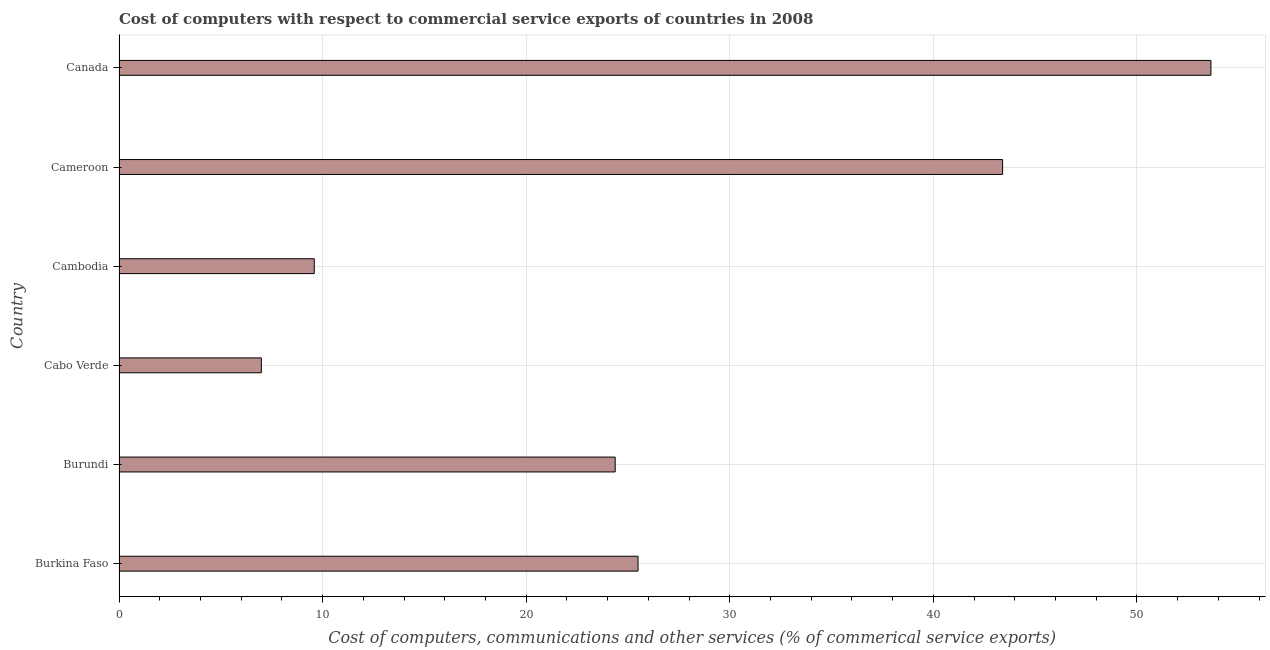Does the graph contain any zero values?
Ensure brevity in your answer.  No. What is the title of the graph?
Make the answer very short. Cost of computers with respect to commercial service exports of countries in 2008. What is the label or title of the X-axis?
Keep it short and to the point. Cost of computers, communications and other services (% of commerical service exports). What is the cost of communications in Cabo Verde?
Give a very brief answer. 6.99. Across all countries, what is the maximum  computer and other services?
Keep it short and to the point. 53.63. Across all countries, what is the minimum  computer and other services?
Your answer should be compact. 6.99. In which country was the  computer and other services minimum?
Keep it short and to the point. Cabo Verde. What is the sum of the cost of communications?
Your answer should be compact. 163.47. What is the difference between the cost of communications in Burkina Faso and Cambodia?
Provide a succinct answer. 15.9. What is the average cost of communications per country?
Offer a terse response. 27.25. What is the median cost of communications?
Provide a short and direct response. 24.93. In how many countries, is the cost of communications greater than 50 %?
Offer a very short reply. 1. What is the ratio of the cost of communications in Burundi to that in Cambodia?
Ensure brevity in your answer.  2.54. What is the difference between the highest and the second highest  computer and other services?
Provide a succinct answer. 10.23. Is the sum of the cost of communications in Cabo Verde and Cambodia greater than the maximum cost of communications across all countries?
Provide a succinct answer. No. What is the difference between the highest and the lowest  computer and other services?
Your answer should be very brief. 46.64. How many bars are there?
Provide a short and direct response. 6. How many countries are there in the graph?
Your answer should be very brief. 6. What is the difference between two consecutive major ticks on the X-axis?
Provide a succinct answer. 10. Are the values on the major ticks of X-axis written in scientific E-notation?
Your response must be concise. No. What is the Cost of computers, communications and other services (% of commerical service exports) of Burkina Faso?
Ensure brevity in your answer.  25.49. What is the Cost of computers, communications and other services (% of commerical service exports) in Burundi?
Your answer should be very brief. 24.37. What is the Cost of computers, communications and other services (% of commerical service exports) in Cabo Verde?
Offer a terse response. 6.99. What is the Cost of computers, communications and other services (% of commerical service exports) in Cambodia?
Make the answer very short. 9.59. What is the Cost of computers, communications and other services (% of commerical service exports) in Cameroon?
Make the answer very short. 43.4. What is the Cost of computers, communications and other services (% of commerical service exports) of Canada?
Give a very brief answer. 53.63. What is the difference between the Cost of computers, communications and other services (% of commerical service exports) in Burkina Faso and Burundi?
Provide a short and direct response. 1.12. What is the difference between the Cost of computers, communications and other services (% of commerical service exports) in Burkina Faso and Cabo Verde?
Offer a very short reply. 18.5. What is the difference between the Cost of computers, communications and other services (% of commerical service exports) in Burkina Faso and Cambodia?
Give a very brief answer. 15.9. What is the difference between the Cost of computers, communications and other services (% of commerical service exports) in Burkina Faso and Cameroon?
Provide a succinct answer. -17.91. What is the difference between the Cost of computers, communications and other services (% of commerical service exports) in Burkina Faso and Canada?
Make the answer very short. -28.14. What is the difference between the Cost of computers, communications and other services (% of commerical service exports) in Burundi and Cabo Verde?
Give a very brief answer. 17.38. What is the difference between the Cost of computers, communications and other services (% of commerical service exports) in Burundi and Cambodia?
Offer a terse response. 14.78. What is the difference between the Cost of computers, communications and other services (% of commerical service exports) in Burundi and Cameroon?
Keep it short and to the point. -19.03. What is the difference between the Cost of computers, communications and other services (% of commerical service exports) in Burundi and Canada?
Provide a short and direct response. -29.26. What is the difference between the Cost of computers, communications and other services (% of commerical service exports) in Cabo Verde and Cambodia?
Keep it short and to the point. -2.6. What is the difference between the Cost of computers, communications and other services (% of commerical service exports) in Cabo Verde and Cameroon?
Provide a short and direct response. -36.41. What is the difference between the Cost of computers, communications and other services (% of commerical service exports) in Cabo Verde and Canada?
Provide a short and direct response. -46.64. What is the difference between the Cost of computers, communications and other services (% of commerical service exports) in Cambodia and Cameroon?
Keep it short and to the point. -33.81. What is the difference between the Cost of computers, communications and other services (% of commerical service exports) in Cambodia and Canada?
Keep it short and to the point. -44.04. What is the difference between the Cost of computers, communications and other services (% of commerical service exports) in Cameroon and Canada?
Your answer should be very brief. -10.23. What is the ratio of the Cost of computers, communications and other services (% of commerical service exports) in Burkina Faso to that in Burundi?
Ensure brevity in your answer.  1.05. What is the ratio of the Cost of computers, communications and other services (% of commerical service exports) in Burkina Faso to that in Cabo Verde?
Offer a very short reply. 3.65. What is the ratio of the Cost of computers, communications and other services (% of commerical service exports) in Burkina Faso to that in Cambodia?
Make the answer very short. 2.66. What is the ratio of the Cost of computers, communications and other services (% of commerical service exports) in Burkina Faso to that in Cameroon?
Make the answer very short. 0.59. What is the ratio of the Cost of computers, communications and other services (% of commerical service exports) in Burkina Faso to that in Canada?
Offer a very short reply. 0.47. What is the ratio of the Cost of computers, communications and other services (% of commerical service exports) in Burundi to that in Cabo Verde?
Your answer should be compact. 3.49. What is the ratio of the Cost of computers, communications and other services (% of commerical service exports) in Burundi to that in Cambodia?
Provide a short and direct response. 2.54. What is the ratio of the Cost of computers, communications and other services (% of commerical service exports) in Burundi to that in Cameroon?
Your response must be concise. 0.56. What is the ratio of the Cost of computers, communications and other services (% of commerical service exports) in Burundi to that in Canada?
Keep it short and to the point. 0.45. What is the ratio of the Cost of computers, communications and other services (% of commerical service exports) in Cabo Verde to that in Cambodia?
Keep it short and to the point. 0.73. What is the ratio of the Cost of computers, communications and other services (% of commerical service exports) in Cabo Verde to that in Cameroon?
Your answer should be compact. 0.16. What is the ratio of the Cost of computers, communications and other services (% of commerical service exports) in Cabo Verde to that in Canada?
Ensure brevity in your answer.  0.13. What is the ratio of the Cost of computers, communications and other services (% of commerical service exports) in Cambodia to that in Cameroon?
Give a very brief answer. 0.22. What is the ratio of the Cost of computers, communications and other services (% of commerical service exports) in Cambodia to that in Canada?
Offer a very short reply. 0.18. What is the ratio of the Cost of computers, communications and other services (% of commerical service exports) in Cameroon to that in Canada?
Give a very brief answer. 0.81. 